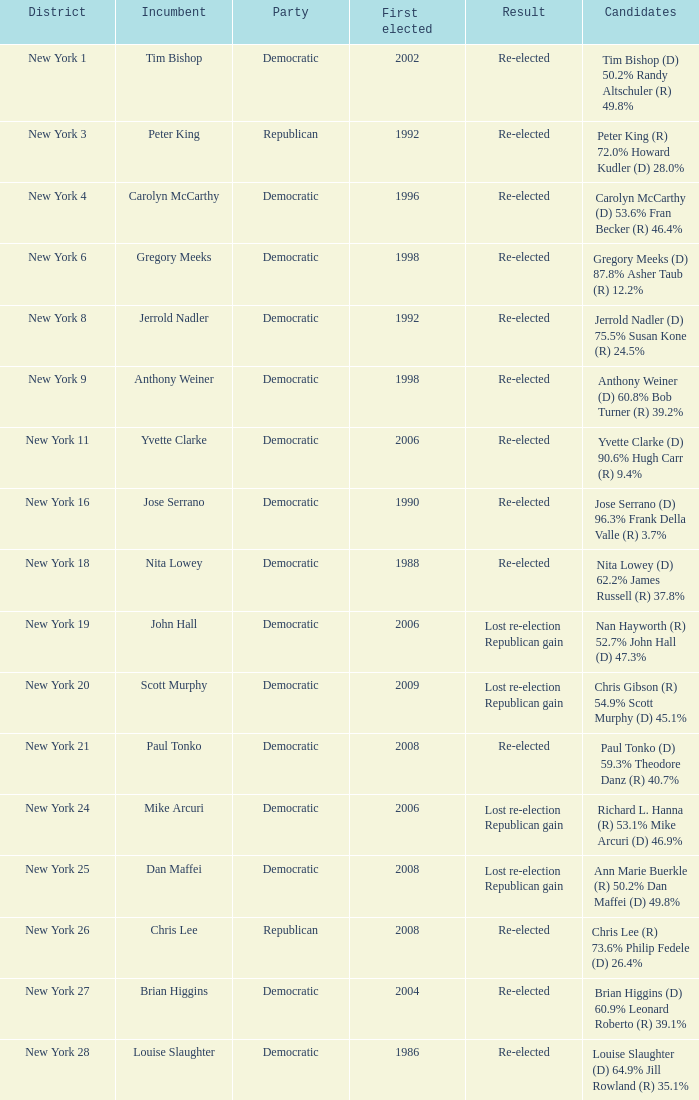Name the party for new york 4 Democratic. 